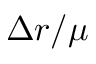<formula> <loc_0><loc_0><loc_500><loc_500>\Delta r / \mu</formula> 